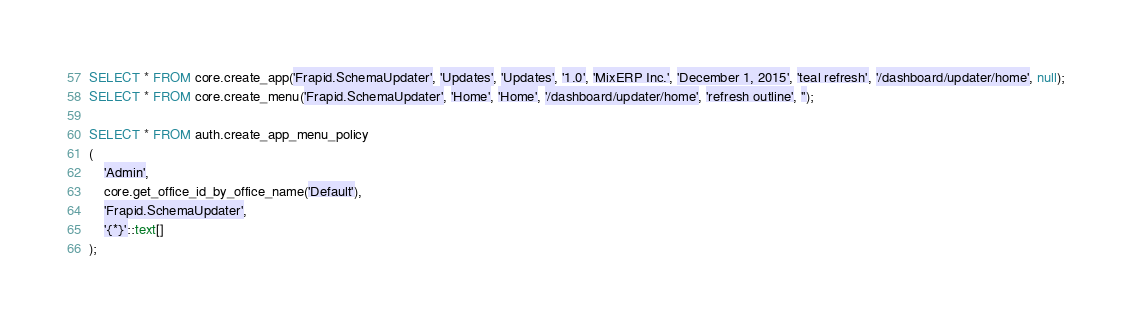Convert code to text. <code><loc_0><loc_0><loc_500><loc_500><_SQL_>SELECT * FROM core.create_app('Frapid.SchemaUpdater', 'Updates', 'Updates', '1.0', 'MixERP Inc.', 'December 1, 2015', 'teal refresh', '/dashboard/updater/home', null);
SELECT * FROM core.create_menu('Frapid.SchemaUpdater', 'Home', 'Home', '/dashboard/updater/home', 'refresh outline', '');

SELECT * FROM auth.create_app_menu_policy
(
    'Admin', 
    core.get_office_id_by_office_name('Default'), 
    'Frapid.SchemaUpdater',
    '{*}'::text[]
);</code> 